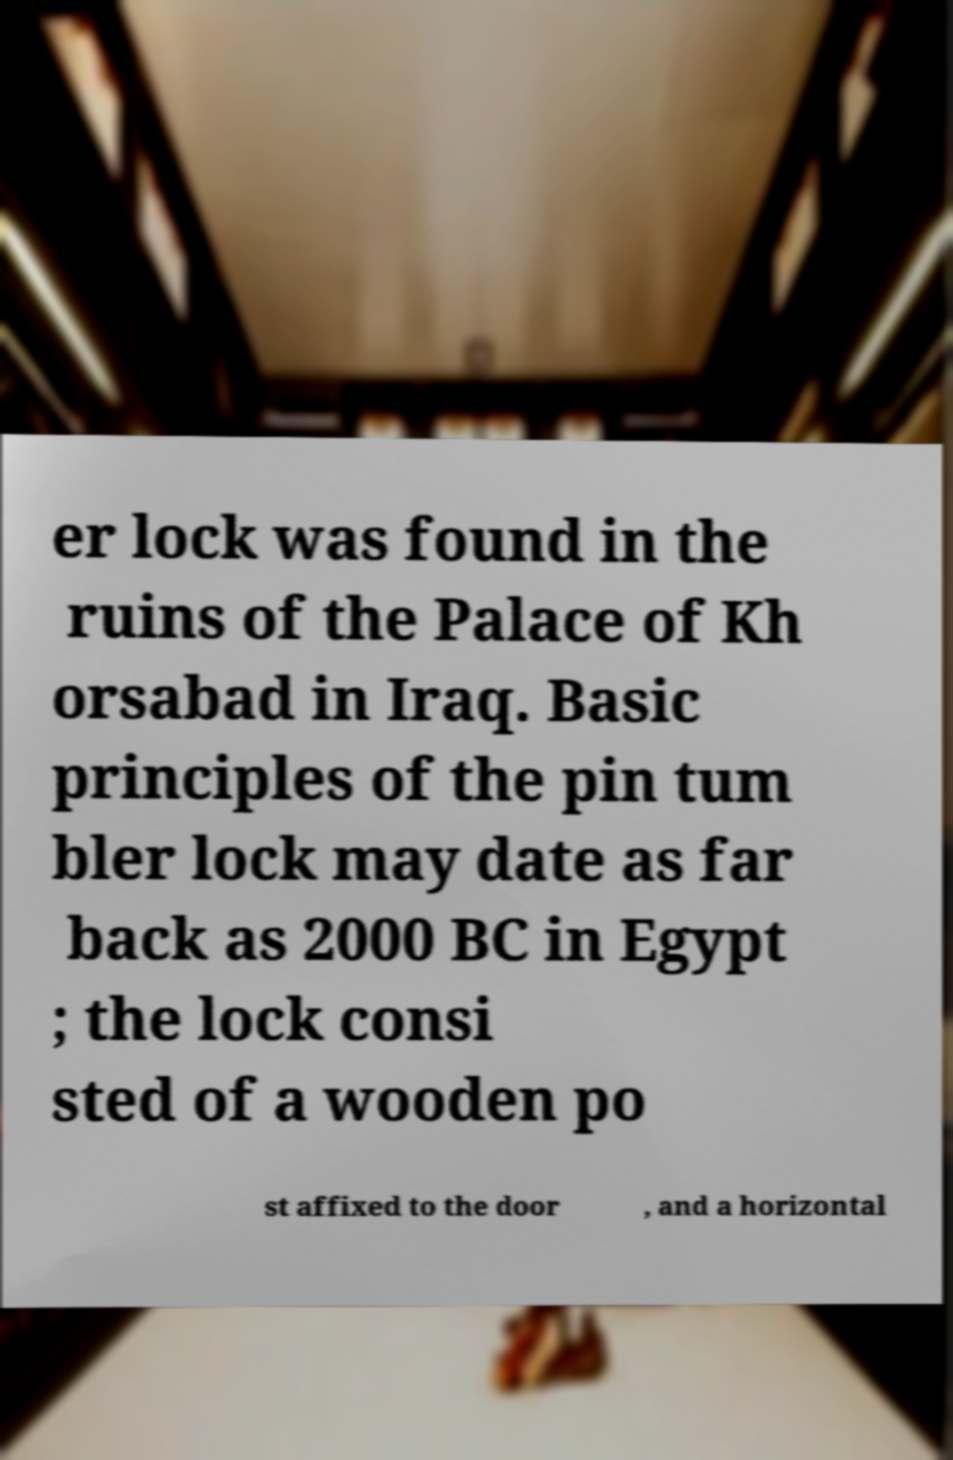Can you accurately transcribe the text from the provided image for me? er lock was found in the ruins of the Palace of Kh orsabad in Iraq. Basic principles of the pin tum bler lock may date as far back as 2000 BC in Egypt ; the lock consi sted of a wooden po st affixed to the door , and a horizontal 